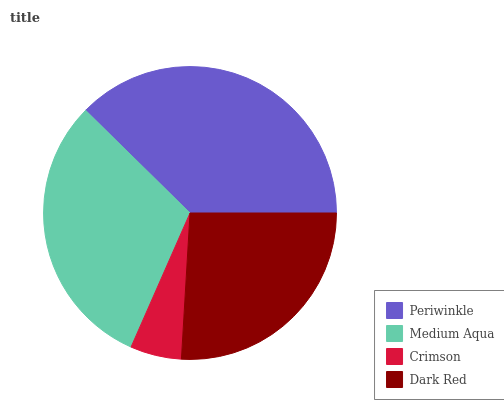Is Crimson the minimum?
Answer yes or no. Yes. Is Periwinkle the maximum?
Answer yes or no. Yes. Is Medium Aqua the minimum?
Answer yes or no. No. Is Medium Aqua the maximum?
Answer yes or no. No. Is Periwinkle greater than Medium Aqua?
Answer yes or no. Yes. Is Medium Aqua less than Periwinkle?
Answer yes or no. Yes. Is Medium Aqua greater than Periwinkle?
Answer yes or no. No. Is Periwinkle less than Medium Aqua?
Answer yes or no. No. Is Medium Aqua the high median?
Answer yes or no. Yes. Is Dark Red the low median?
Answer yes or no. Yes. Is Periwinkle the high median?
Answer yes or no. No. Is Periwinkle the low median?
Answer yes or no. No. 